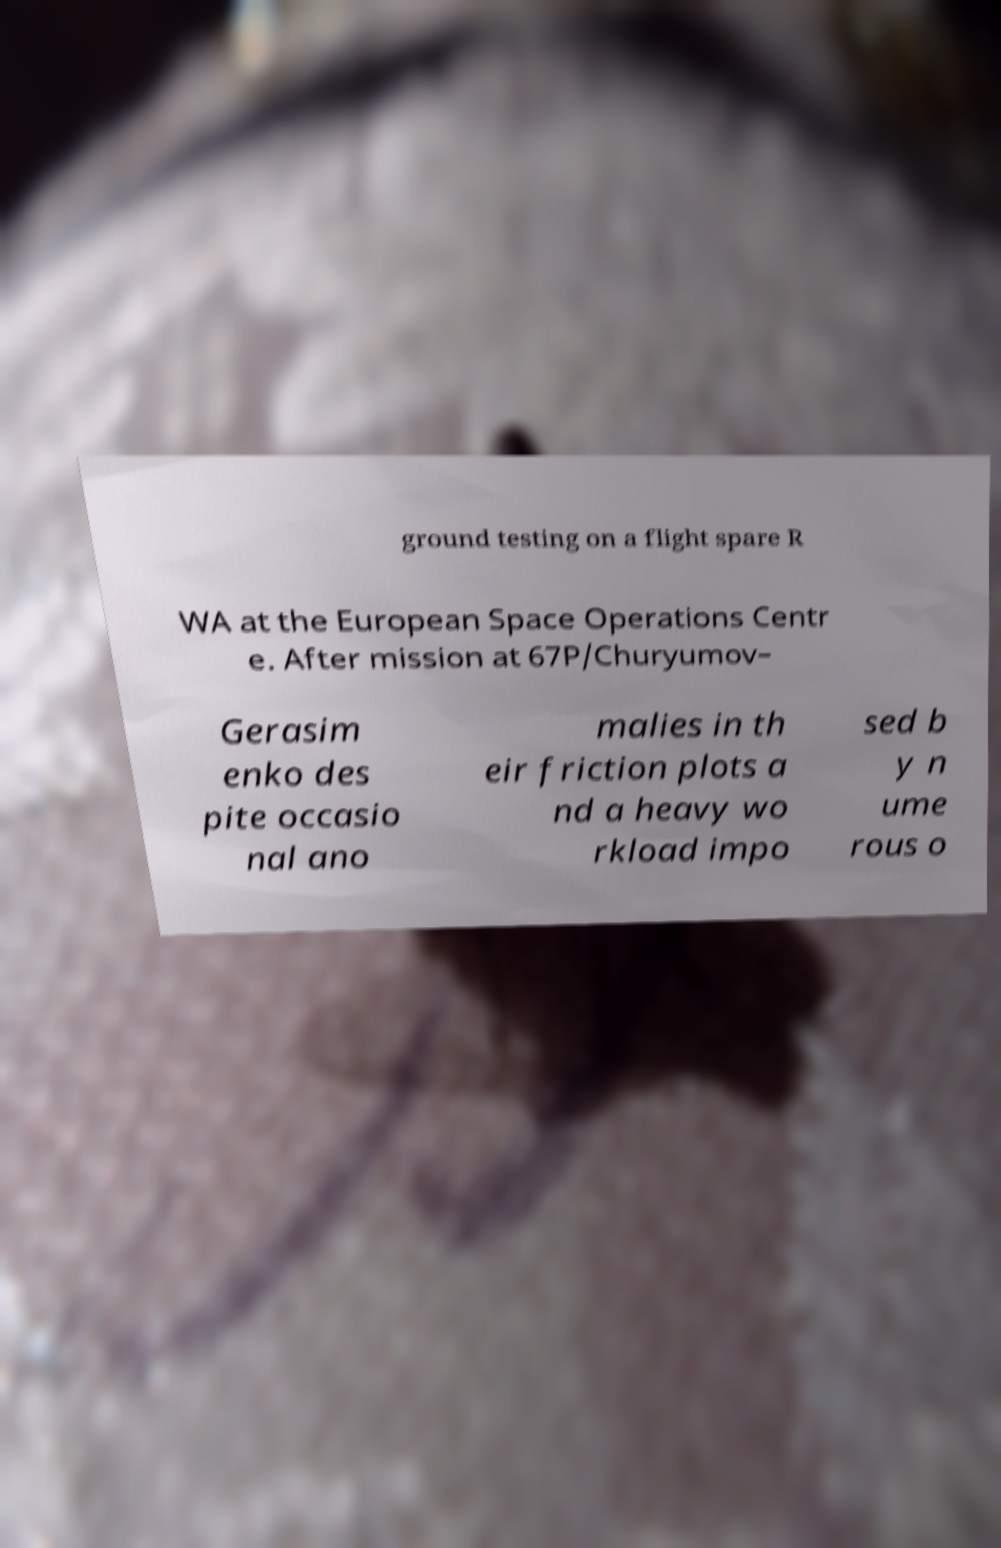Please identify and transcribe the text found in this image. ground testing on a flight spare R WA at the European Space Operations Centr e. After mission at 67P/Churyumov– Gerasim enko des pite occasio nal ano malies in th eir friction plots a nd a heavy wo rkload impo sed b y n ume rous o 